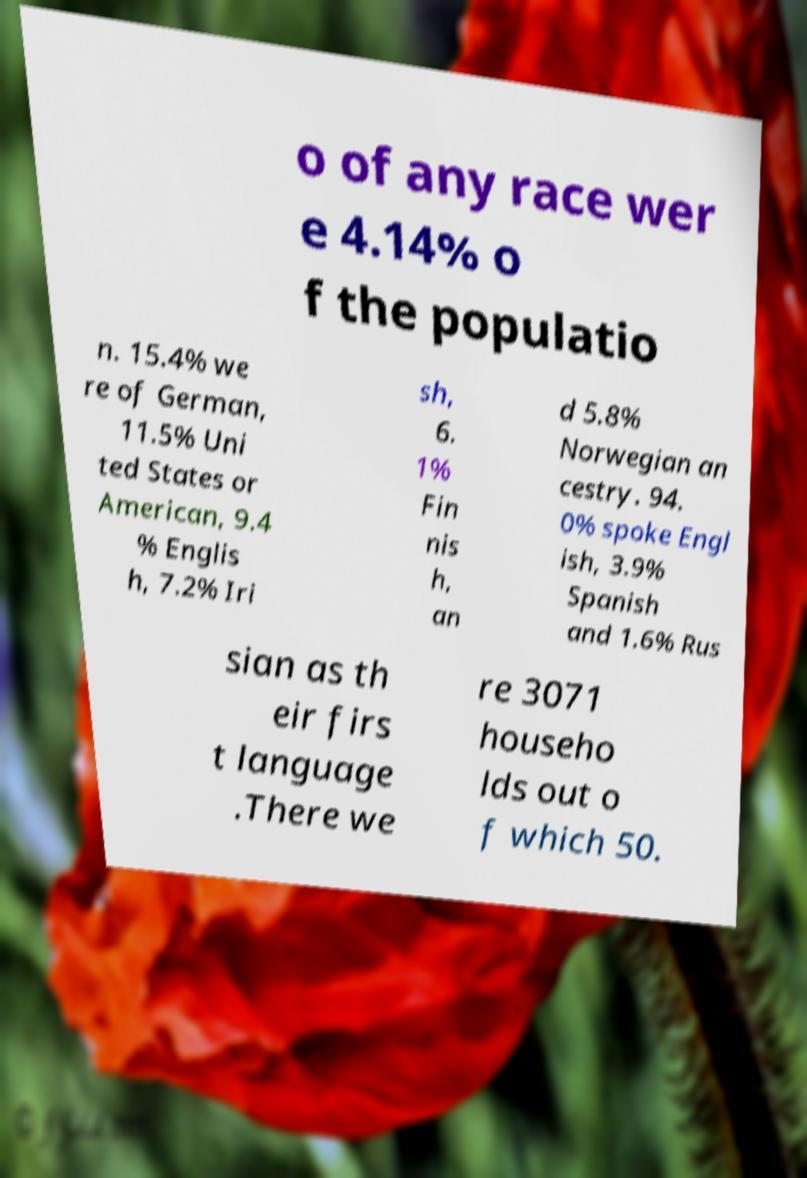Could you extract and type out the text from this image? o of any race wer e 4.14% o f the populatio n. 15.4% we re of German, 11.5% Uni ted States or American, 9.4 % Englis h, 7.2% Iri sh, 6. 1% Fin nis h, an d 5.8% Norwegian an cestry. 94. 0% spoke Engl ish, 3.9% Spanish and 1.6% Rus sian as th eir firs t language .There we re 3071 househo lds out o f which 50. 